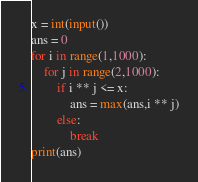<code> <loc_0><loc_0><loc_500><loc_500><_Python_>x = int(input())
ans = 0
for i in range(1,1000):
    for j in range(2,1000):
        if i ** j <= x:
            ans = max(ans,i ** j)
        else:
            break
print(ans)</code> 